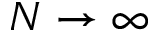<formula> <loc_0><loc_0><loc_500><loc_500>N \to \infty</formula> 